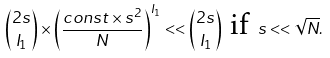Convert formula to latex. <formula><loc_0><loc_0><loc_500><loc_500>\binom { 2 s } { I _ { 1 } } \times \left ( \frac { c o n s t \times s ^ { 2 } } { N } \right ) ^ { I _ { 1 } } < < \binom { 2 s } { I _ { 1 } } \text { if } s < < \sqrt { N } .</formula> 